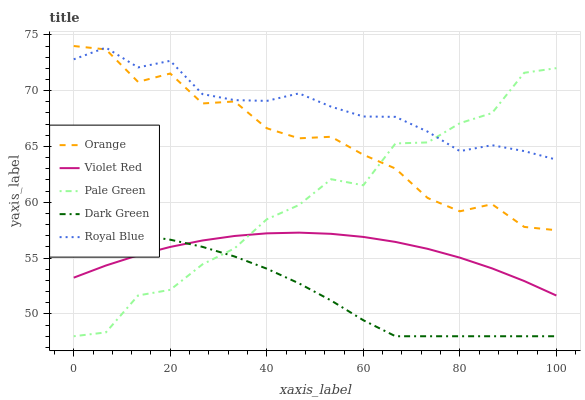Does Dark Green have the minimum area under the curve?
Answer yes or no. Yes. Does Royal Blue have the maximum area under the curve?
Answer yes or no. Yes. Does Violet Red have the minimum area under the curve?
Answer yes or no. No. Does Violet Red have the maximum area under the curve?
Answer yes or no. No. Is Violet Red the smoothest?
Answer yes or no. Yes. Is Pale Green the roughest?
Answer yes or no. Yes. Is Royal Blue the smoothest?
Answer yes or no. No. Is Royal Blue the roughest?
Answer yes or no. No. Does Pale Green have the lowest value?
Answer yes or no. Yes. Does Violet Red have the lowest value?
Answer yes or no. No. Does Orange have the highest value?
Answer yes or no. Yes. Does Royal Blue have the highest value?
Answer yes or no. No. Is Dark Green less than Orange?
Answer yes or no. Yes. Is Royal Blue greater than Violet Red?
Answer yes or no. Yes. Does Dark Green intersect Violet Red?
Answer yes or no. Yes. Is Dark Green less than Violet Red?
Answer yes or no. No. Is Dark Green greater than Violet Red?
Answer yes or no. No. Does Dark Green intersect Orange?
Answer yes or no. No. 